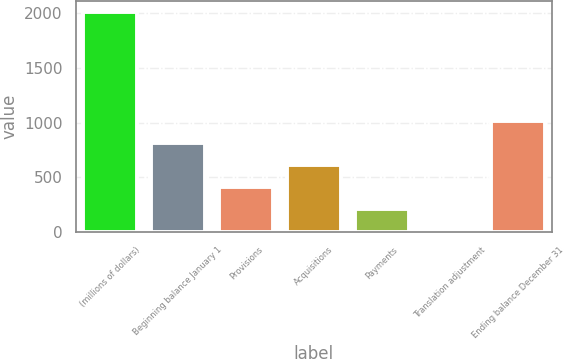Convert chart to OTSL. <chart><loc_0><loc_0><loc_500><loc_500><bar_chart><fcel>(millions of dollars)<fcel>Beginning balance January 1<fcel>Provisions<fcel>Acquisitions<fcel>Payments<fcel>Translation adjustment<fcel>Ending balance December 31<nl><fcel>2014<fcel>812.44<fcel>411.92<fcel>612.18<fcel>211.66<fcel>11.4<fcel>1012.7<nl></chart> 